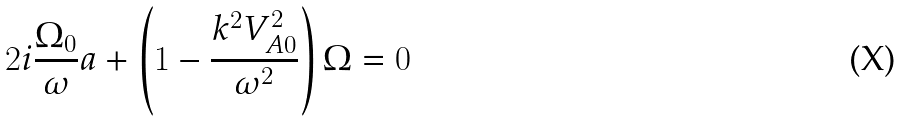Convert formula to latex. <formula><loc_0><loc_0><loc_500><loc_500>2 i \frac { \Omega _ { 0 } } { \omega } a + \left ( 1 - \frac { k ^ { 2 } V _ { A 0 } ^ { 2 } } { \omega ^ { 2 } } \right ) \Omega = 0</formula> 